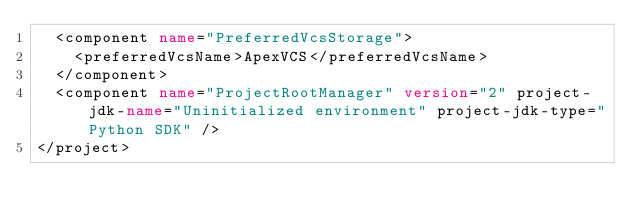<code> <loc_0><loc_0><loc_500><loc_500><_XML_>  <component name="PreferredVcsStorage">
    <preferredVcsName>ApexVCS</preferredVcsName>
  </component>
  <component name="ProjectRootManager" version="2" project-jdk-name="Uninitialized environment" project-jdk-type="Python SDK" />
</project></code> 